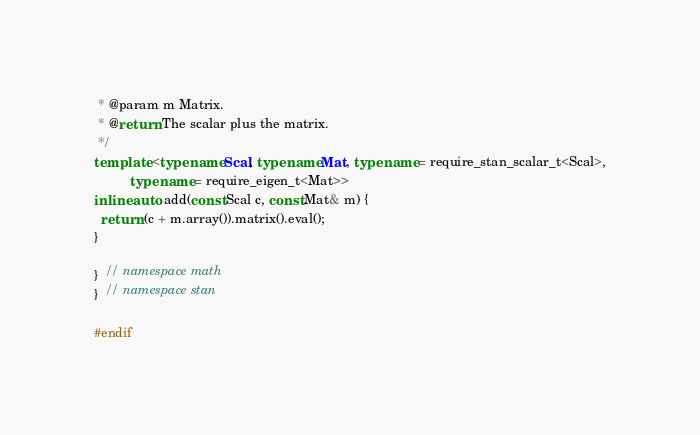Convert code to text. <code><loc_0><loc_0><loc_500><loc_500><_C++_> * @param m Matrix.
 * @return The scalar plus the matrix.
 */
template <typename Scal, typename Mat, typename = require_stan_scalar_t<Scal>,
          typename = require_eigen_t<Mat>>
inline auto add(const Scal c, const Mat& m) {
  return (c + m.array()).matrix().eval();
}

}  // namespace math
}  // namespace stan

#endif
</code> 